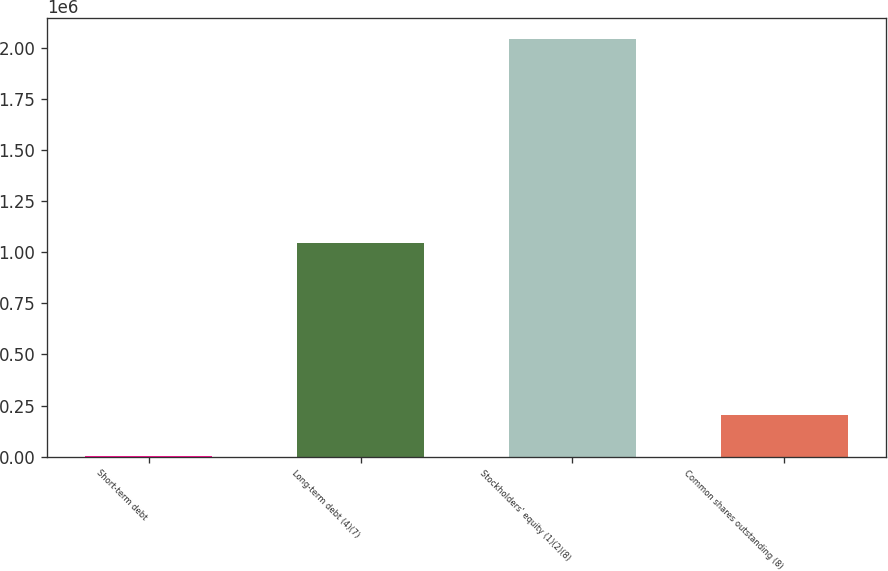Convert chart to OTSL. <chart><loc_0><loc_0><loc_500><loc_500><bar_chart><fcel>Short-term debt<fcel>Long-term debt (4)(7)<fcel>Stockholders' equity (1)(2)(8)<fcel>Common shares outstanding (8)<nl><fcel>1075<fcel>1.04539e+06<fcel>2.0421e+06<fcel>205178<nl></chart> 